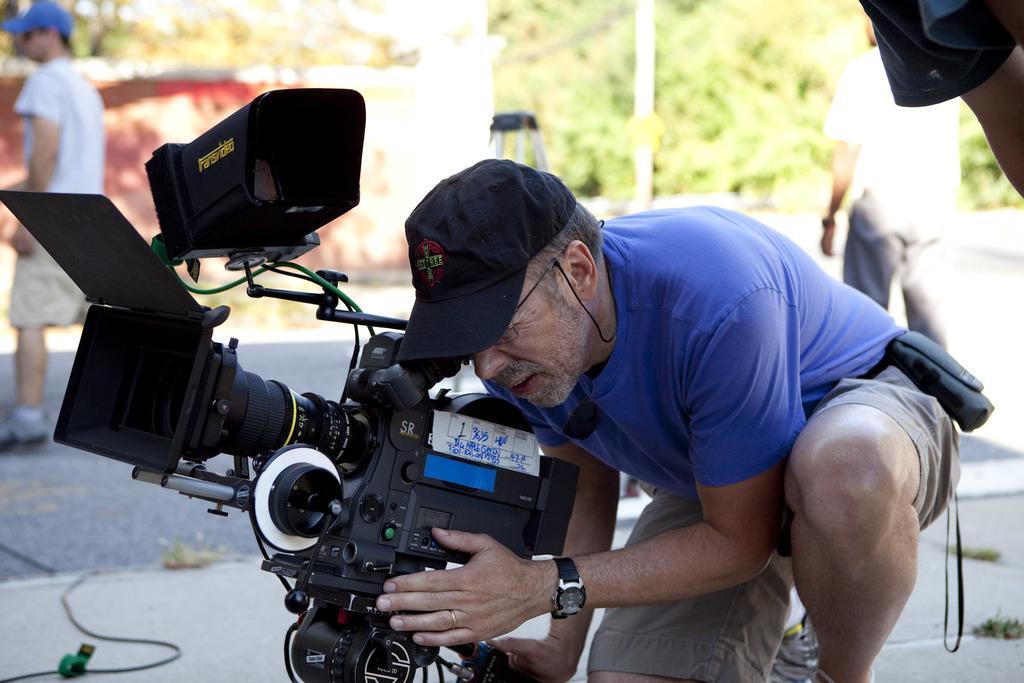In one or two sentences, can you explain what this image depicts? A man in this picture is looking at the camera ,focused and in the background there is camera stand and a guy. There are also trees in the background. 